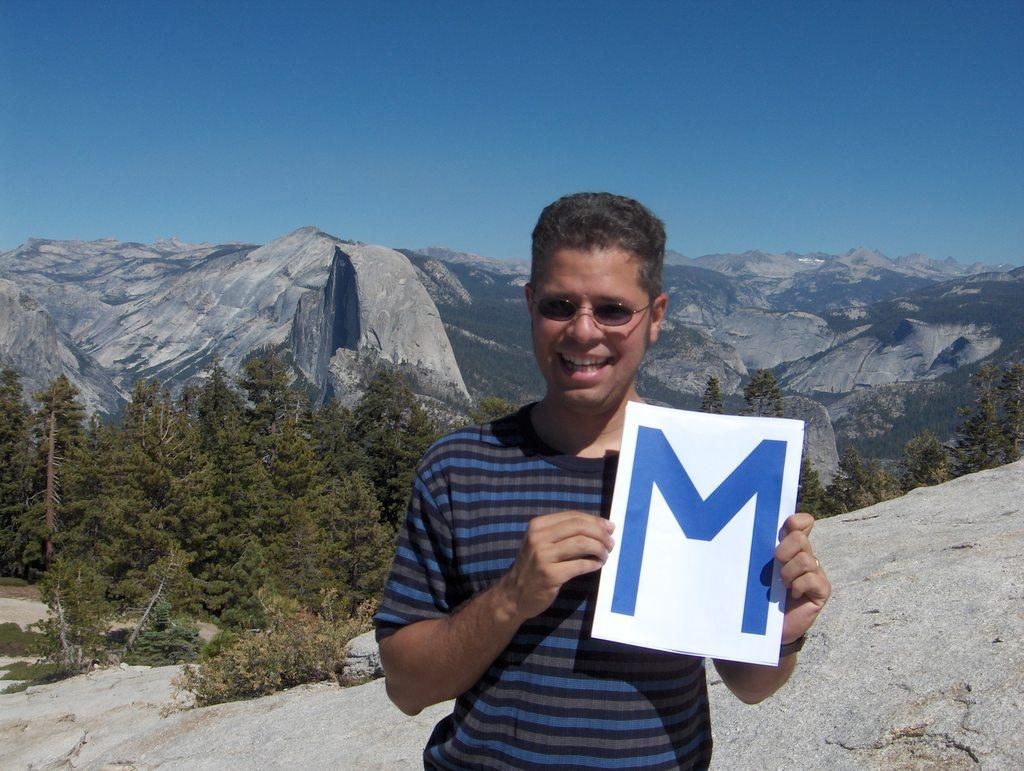What is the man in the image doing? The man is standing in the image and holding a card in his hands. What can be seen in the background of the image? There are hills, trees, and the sky visible in the background of the image. What type of print is on the man's trousers in the image? There is no information about the man's trousers or any print on them in the provided facts. Can you tell me the name of the man's sister in the image? There is no information about the man's sister or any other people in the image in the provided facts. 